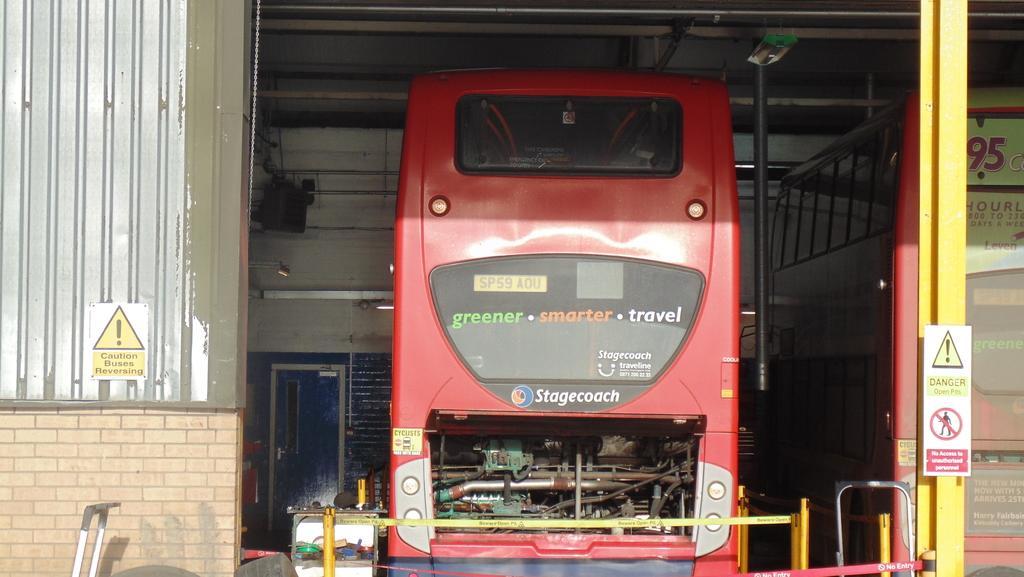Could you give a brief overview of what you see in this image? Here we can see a vehicle, pole, door, boards, and wall. There are objects. 